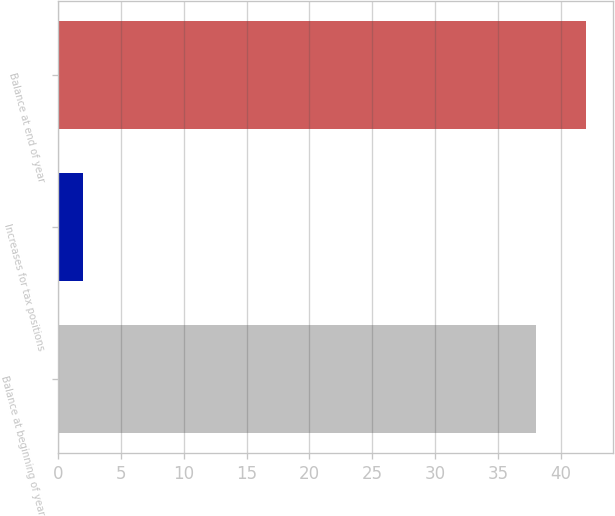<chart> <loc_0><loc_0><loc_500><loc_500><bar_chart><fcel>Balance at beginning of year<fcel>Increases for tax positions<fcel>Balance at end of year<nl><fcel>38<fcel>2<fcel>42<nl></chart> 